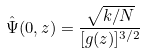Convert formula to latex. <formula><loc_0><loc_0><loc_500><loc_500>\hat { \Psi } ( 0 , z ) = \frac { \sqrt { k / N } } { [ g ( z ) ] ^ { 3 / 2 } }</formula> 